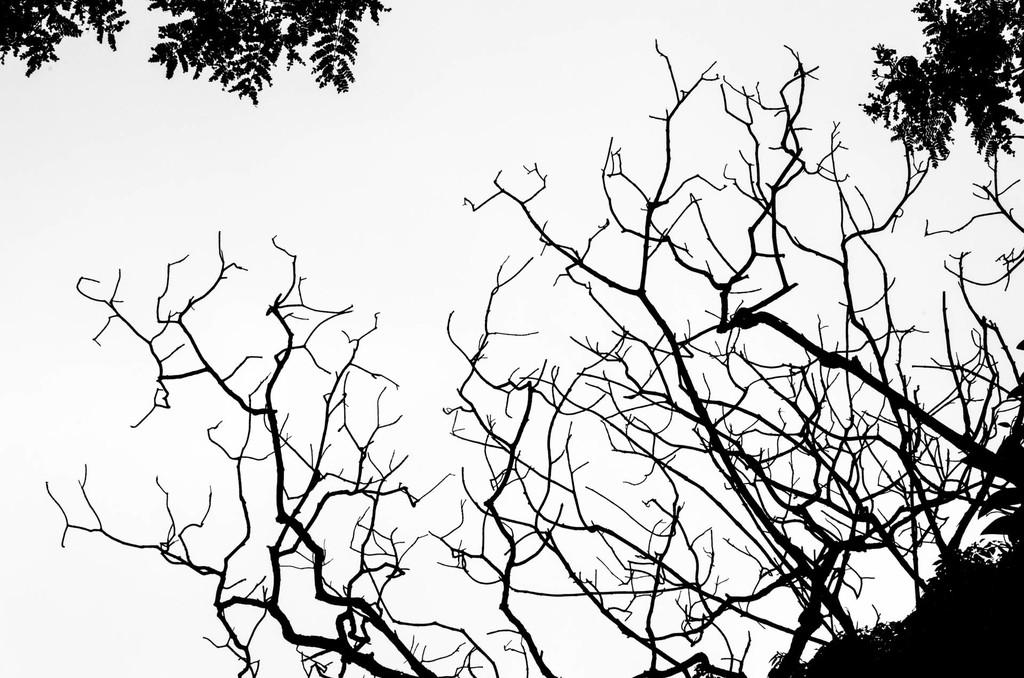What type of photography is the image? The image is a black and white photography. What is the main subject of the photography? The subject of the photography is dry plant branches. What is the tendency of the plant branches to measure the distance between them in the image? There is no indication in the image that the plant branches are measuring anything or have a tendency to do so. 